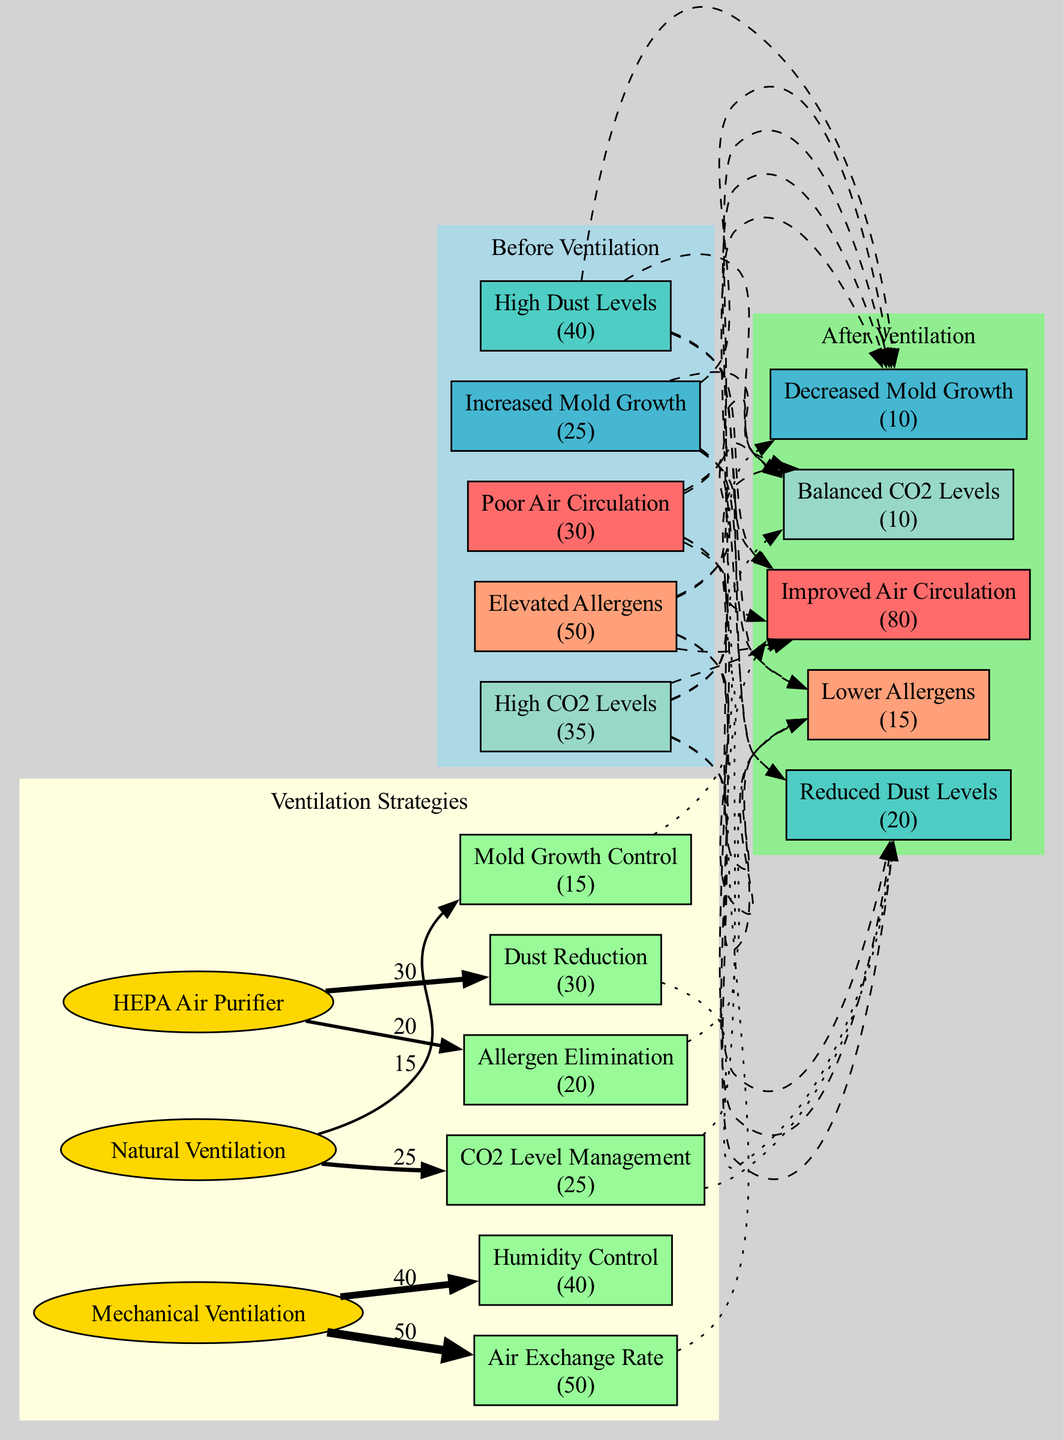What was the level of High Dust Levels before ventilation? According to the diagram, "High Dust Levels" is a specific node in the "Before Ventilation" section, which has a value of 40.
Answer: 40 How many strategies are implemented to address indoor air quality? The diagram lists three distinct ventilation strategies: "HEPA Air Purifier," "Natural Ventilation," and "Mechanical Ventilation."
Answer: 3 What was the percentage of Reduced Dust Levels after ventilation? In the "After Ventilation" section, "Reduced Dust Levels" is a node that displays a value of 20.
Answer: 20 Which ventilation strategy is linked to CO2 Level Management? The diagram indicates that "Natural Ventilation" is the strategy that causes the effect of "CO2 Level Management."
Answer: Natural Ventilation What is the relationship between Elevated Allergens and Lower Allergens? The diagram shows that "Elevated Allergens" (50) is linked to "Lower Allergens" (15) following the implementation of ventilation strategies, indicating a significant reduction.
Answer: Reduction How many nodes represent environmental factors before implementing strategies? The "Before Ventilation" section contains five nodes that represent various environmental conditions including Poor Air Circulation, High Dust Levels, Increased Mold Growth, Elevated Allergens, and High CO2 Levels.
Answer: 5 What is the total reduction in mold growth levels after ventilation strategies are applied? The "Increased Mold Growth" node before ventilation has a value of 25 and "Decreased Mold Growth" after ventilation has a value of 10, leading to a reduction of 15.
Answer: 15 Which strategy is connected to both Dust Reduction and Allergen Elimination? The strategy "HEPA Air Purifier" directly links to the effects of "Dust Reduction" and "Allergen Elimination," forming a connection to two improvement outcomes.
Answer: HEPA Air Purifier What is the percentage of Balanced CO2 Levels after ventilation? The "After Ventilation" section includes the node "Balanced CO2 Levels," which has a value of 10.
Answer: 10 